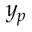<formula> <loc_0><loc_0><loc_500><loc_500>y _ { p }</formula> 